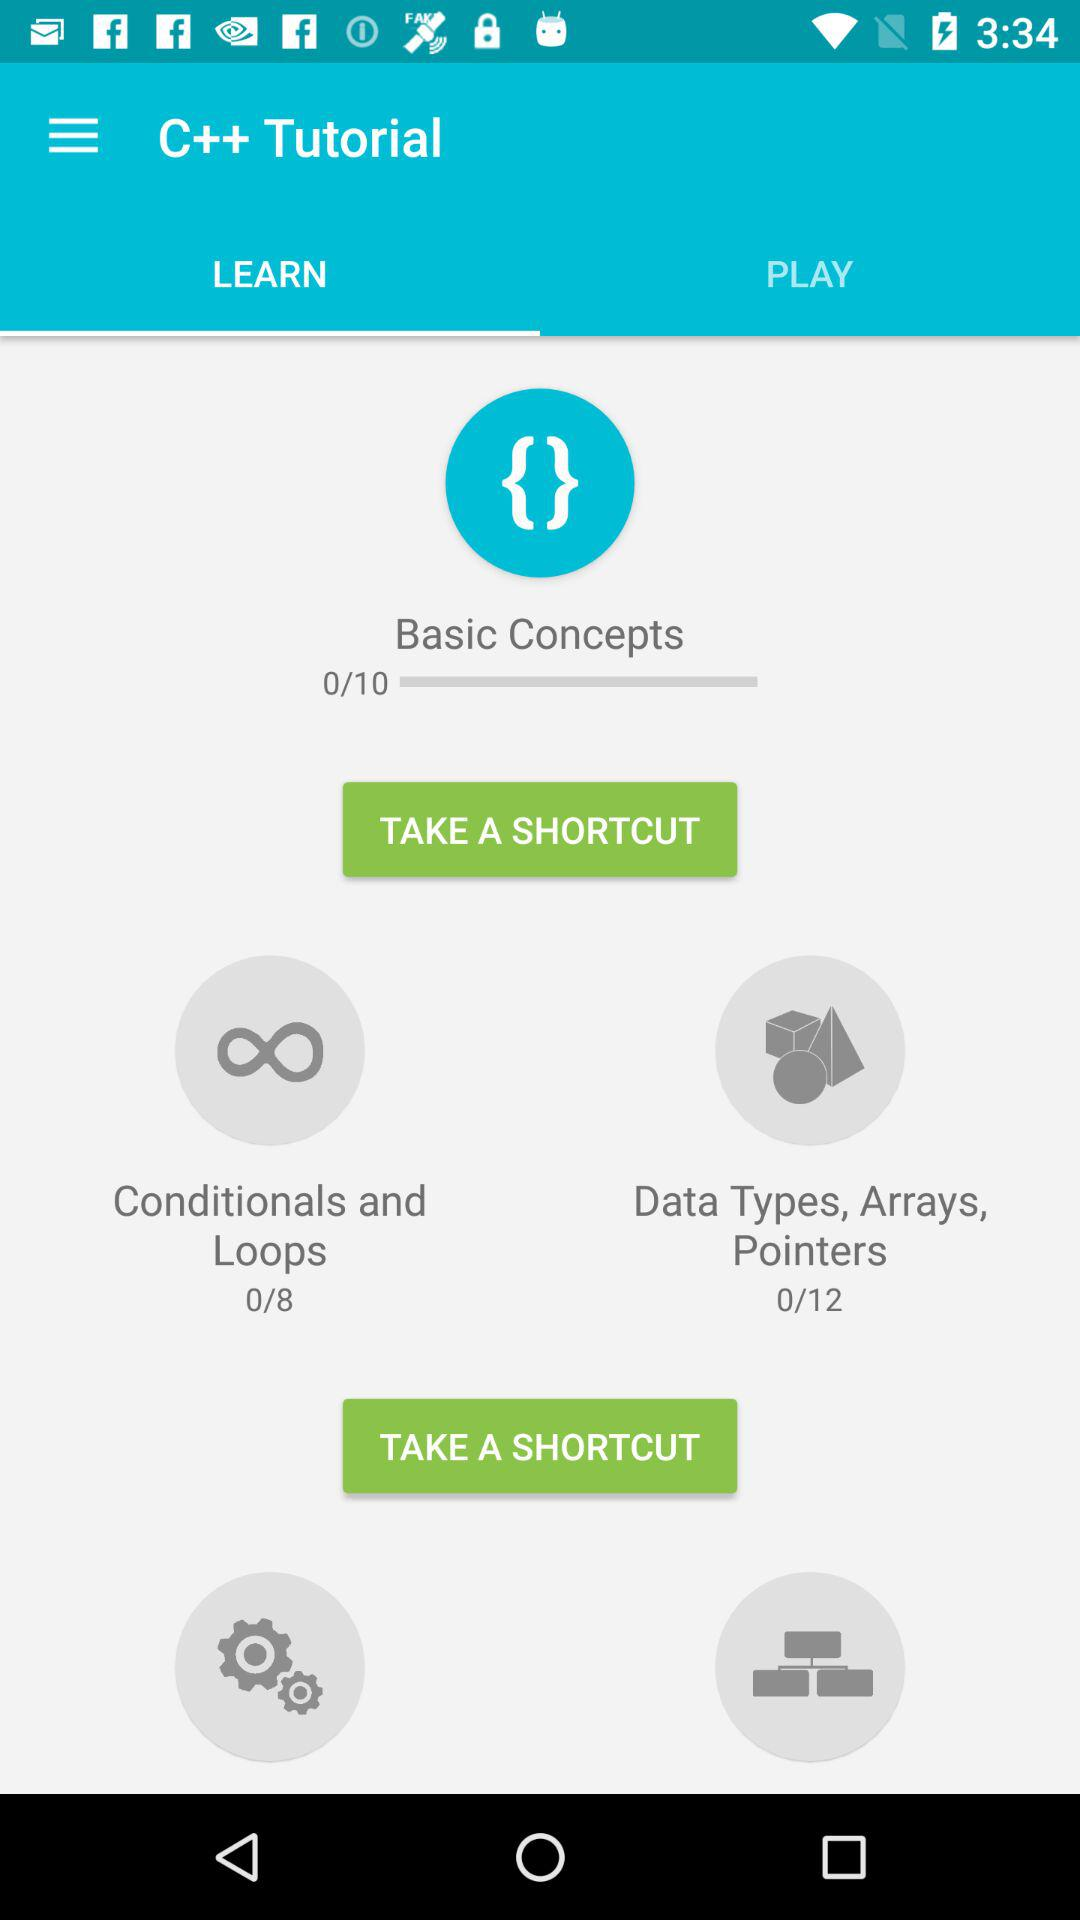How many more lessons are there in the Data Types, Arrays, Pointers section than the Conditionals and Loops section?
Answer the question using a single word or phrase. 4 